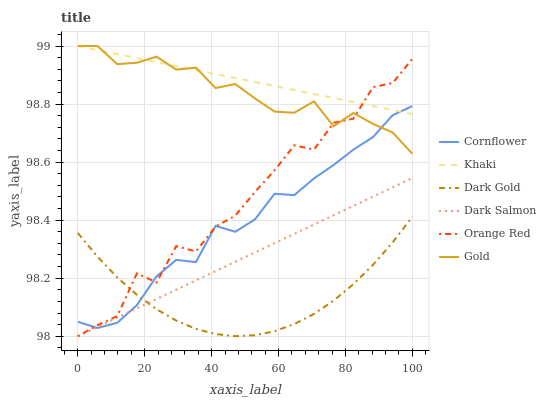Does Dark Gold have the minimum area under the curve?
Answer yes or no. Yes. Does Khaki have the maximum area under the curve?
Answer yes or no. Yes. Does Gold have the minimum area under the curve?
Answer yes or no. No. Does Gold have the maximum area under the curve?
Answer yes or no. No. Is Dark Salmon the smoothest?
Answer yes or no. Yes. Is Orange Red the roughest?
Answer yes or no. Yes. Is Khaki the smoothest?
Answer yes or no. No. Is Khaki the roughest?
Answer yes or no. No. Does Dark Salmon have the lowest value?
Answer yes or no. Yes. Does Gold have the lowest value?
Answer yes or no. No. Does Gold have the highest value?
Answer yes or no. Yes. Does Dark Gold have the highest value?
Answer yes or no. No. Is Dark Gold less than Gold?
Answer yes or no. Yes. Is Gold greater than Dark Salmon?
Answer yes or no. Yes. Does Khaki intersect Gold?
Answer yes or no. Yes. Is Khaki less than Gold?
Answer yes or no. No. Is Khaki greater than Gold?
Answer yes or no. No. Does Dark Gold intersect Gold?
Answer yes or no. No. 